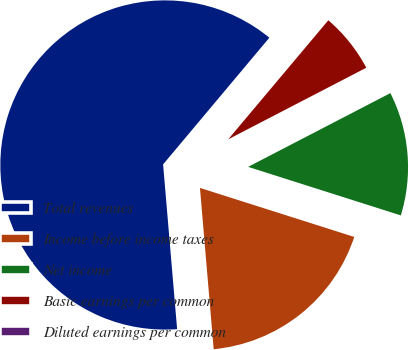Convert chart. <chart><loc_0><loc_0><loc_500><loc_500><pie_chart><fcel>Total revenues<fcel>Income before income taxes<fcel>Net income<fcel>Basic earnings per common<fcel>Diluted earnings per common<nl><fcel>62.46%<fcel>18.75%<fcel>12.51%<fcel>6.26%<fcel>0.02%<nl></chart> 